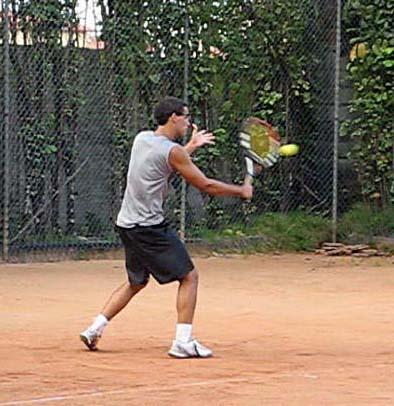Is the man holding the racket with his left or right hand?
Concise answer only. Right. How did the ball get airborne?
Short answer required. Hit. What sport is this?
Keep it brief. Tennis. Color stripping on boys shoe?
Be succinct. Black. What brand are the man's shoes?
Answer briefly. Nike. Is this a grass court?
Answer briefly. No. 